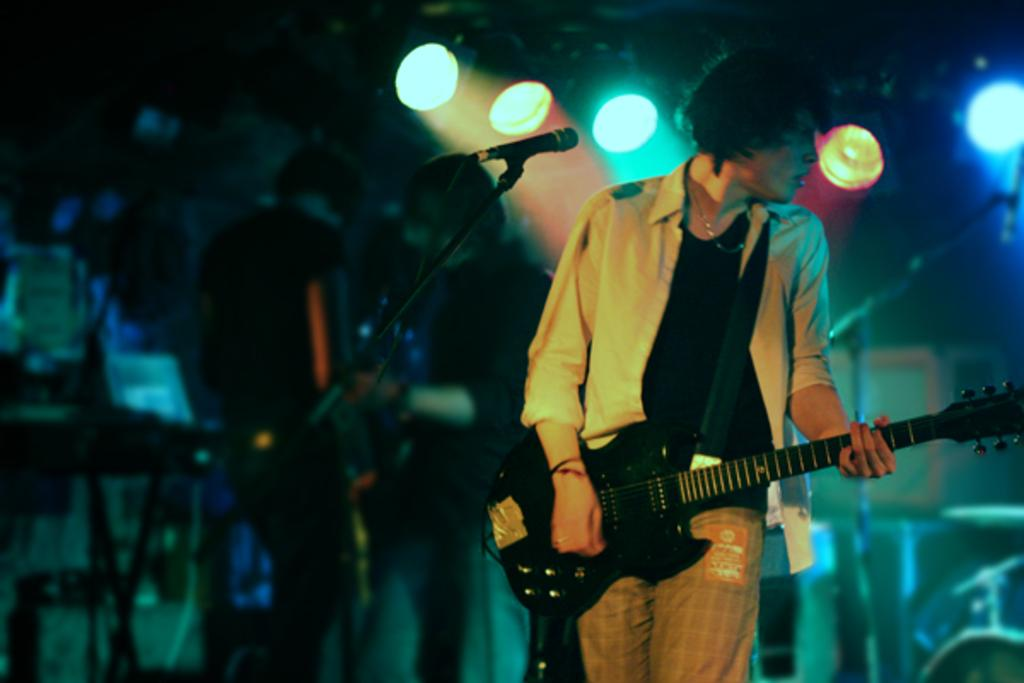Who is present in the image? There is a man in the image. Where is the man located in the image? The man is standing on the right side. What is the man holding in the image? The man is holding a guitar. How is the man dressed in the image? The man is wearing a good dress. What can be seen in the background of the image? There are disco lights behind the man. Are there any other people in the image? Yes, there are people standing on the left side of the image. What type of record can be seen on the branch in the image? There is no record or branch present in the image. What kind of shop is visible in the image? There is no shop visible in the image. 